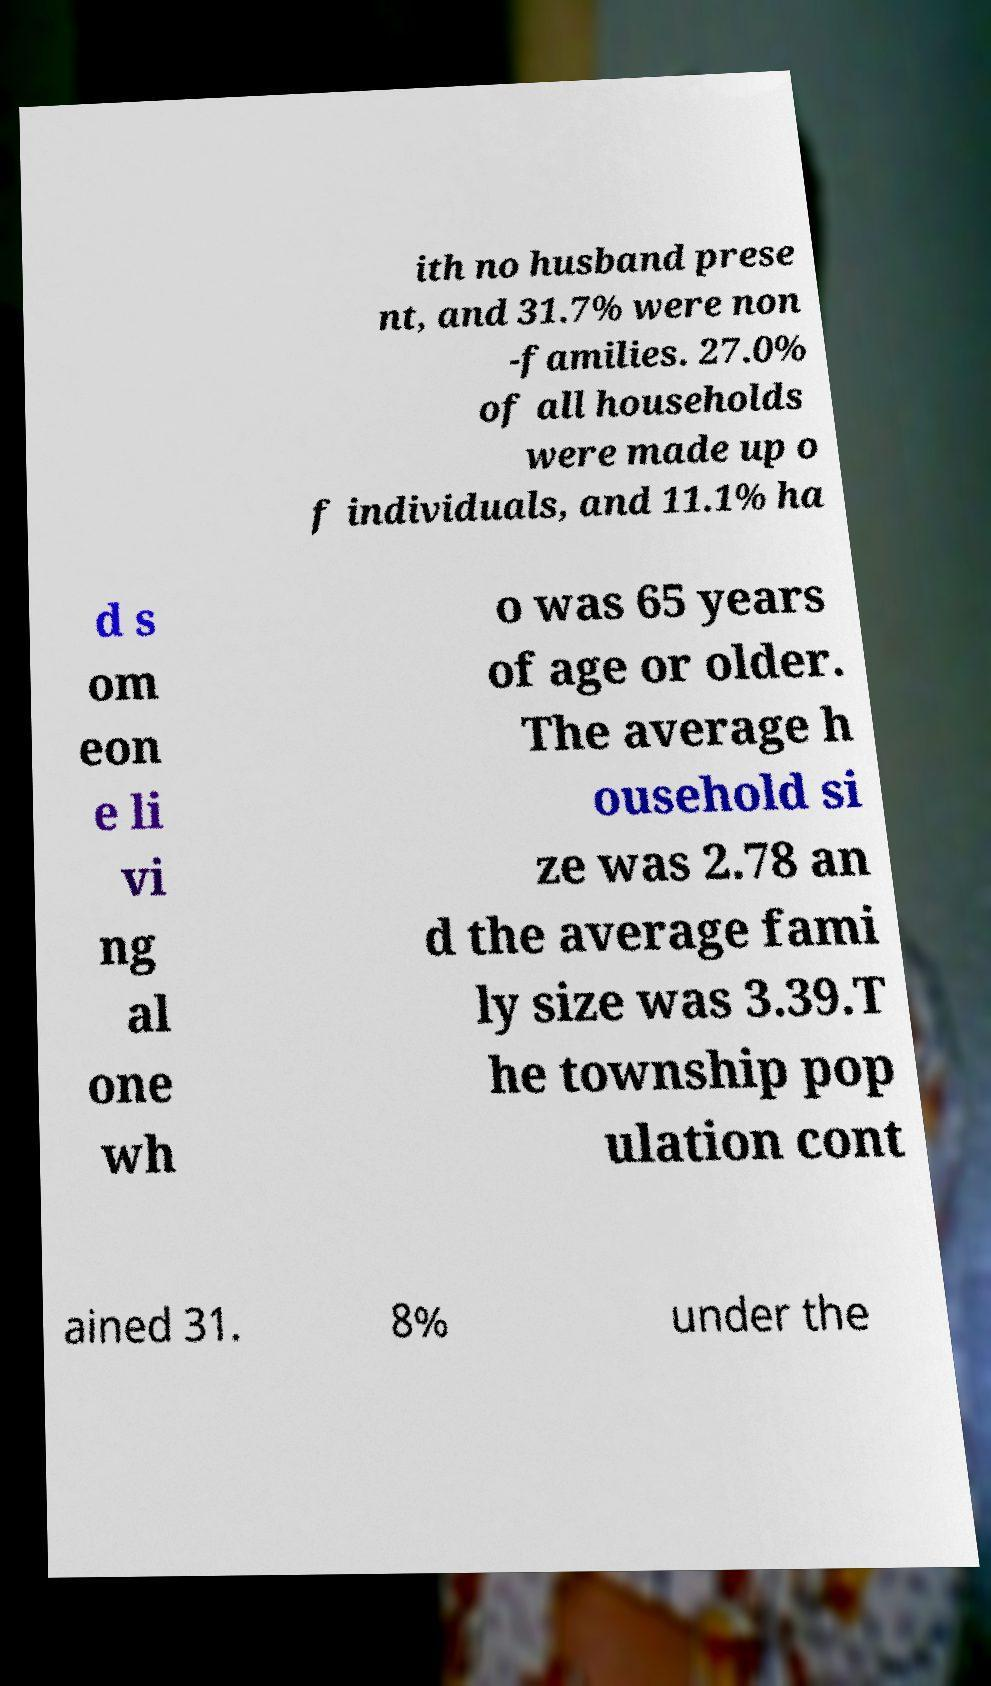What messages or text are displayed in this image? I need them in a readable, typed format. ith no husband prese nt, and 31.7% were non -families. 27.0% of all households were made up o f individuals, and 11.1% ha d s om eon e li vi ng al one wh o was 65 years of age or older. The average h ousehold si ze was 2.78 an d the average fami ly size was 3.39.T he township pop ulation cont ained 31. 8% under the 